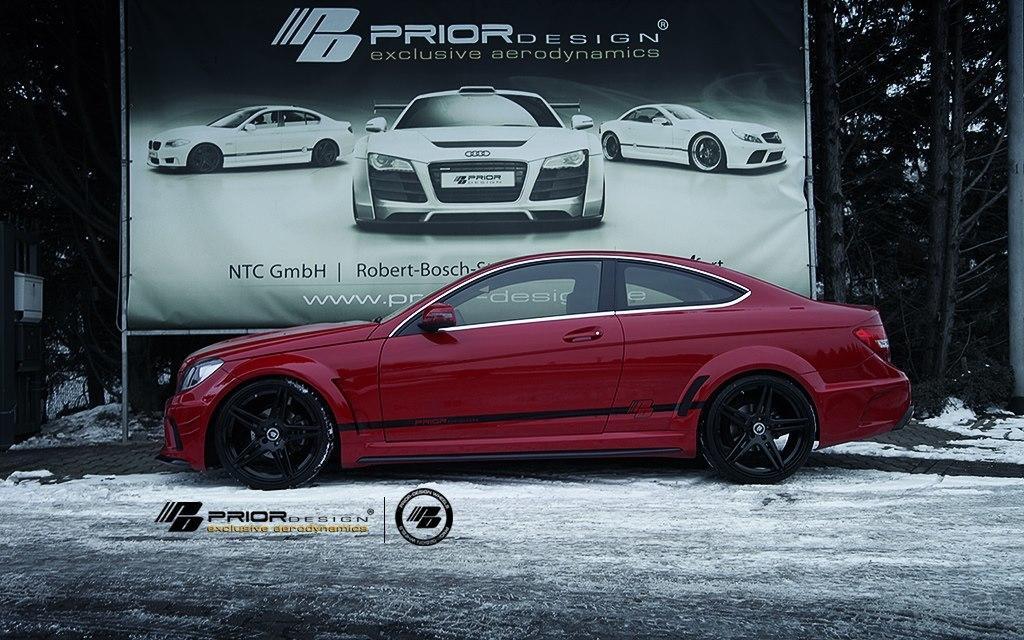Could you give a brief overview of what you see in this image? In this picture I can see there is a car parked here, it has doors, windows and there is a banner in the backdrop and there are trees at left and right sides. There is some snow on the floor. 